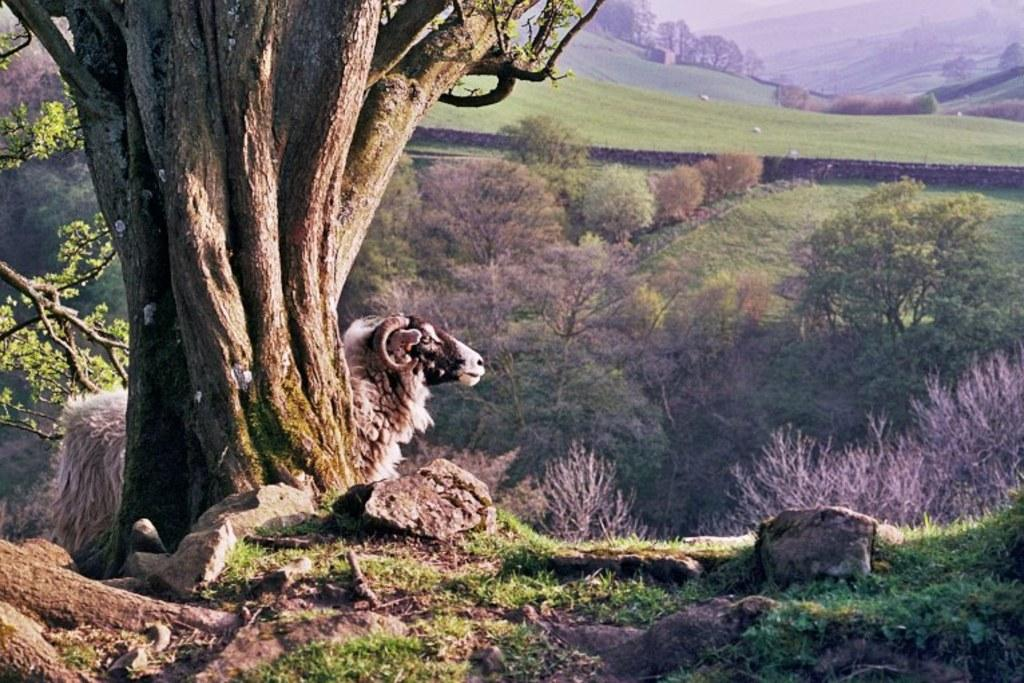What type of animal is in the image? The type of animal cannot be determined from the provided facts. What else can be seen in the image besides the animal? There are stones visible in the image. What can be seen in the background of the image? There are trees in the background of the image. What type of leather is being used by the mother in the image? There is no mention of leather or a mother in the image, so this question cannot be answered. 